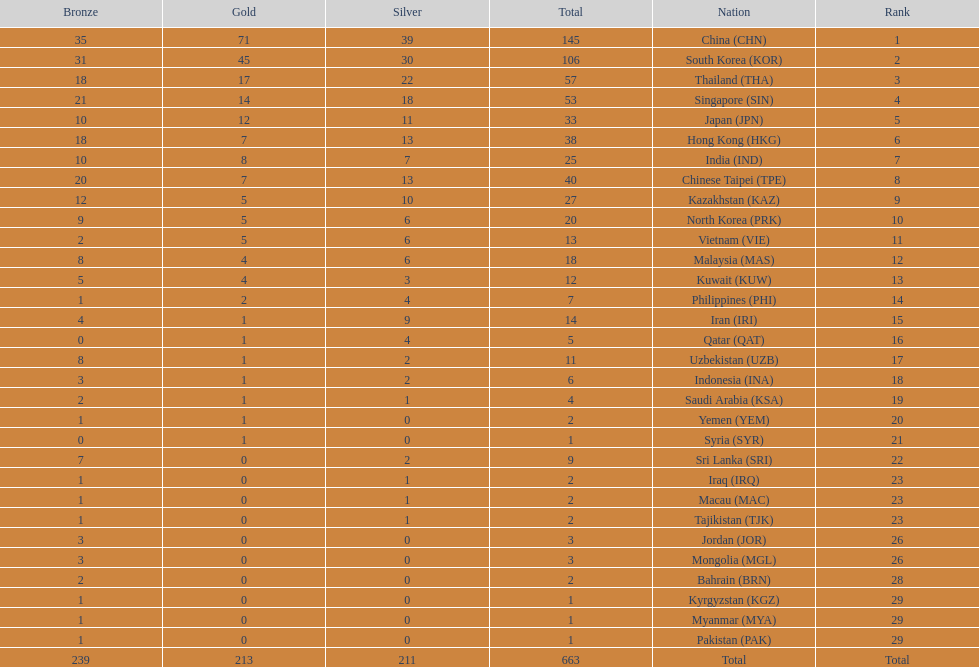Could you parse the entire table? {'header': ['Bronze', 'Gold', 'Silver', 'Total', 'Nation', 'Rank'], 'rows': [['35', '71', '39', '145', 'China\xa0(CHN)', '1'], ['31', '45', '30', '106', 'South Korea\xa0(KOR)', '2'], ['18', '17', '22', '57', 'Thailand\xa0(THA)', '3'], ['21', '14', '18', '53', 'Singapore\xa0(SIN)', '4'], ['10', '12', '11', '33', 'Japan\xa0(JPN)', '5'], ['18', '7', '13', '38', 'Hong Kong\xa0(HKG)', '6'], ['10', '8', '7', '25', 'India\xa0(IND)', '7'], ['20', '7', '13', '40', 'Chinese Taipei\xa0(TPE)', '8'], ['12', '5', '10', '27', 'Kazakhstan\xa0(KAZ)', '9'], ['9', '5', '6', '20', 'North Korea\xa0(PRK)', '10'], ['2', '5', '6', '13', 'Vietnam\xa0(VIE)', '11'], ['8', '4', '6', '18', 'Malaysia\xa0(MAS)', '12'], ['5', '4', '3', '12', 'Kuwait\xa0(KUW)', '13'], ['1', '2', '4', '7', 'Philippines\xa0(PHI)', '14'], ['4', '1', '9', '14', 'Iran\xa0(IRI)', '15'], ['0', '1', '4', '5', 'Qatar\xa0(QAT)', '16'], ['8', '1', '2', '11', 'Uzbekistan\xa0(UZB)', '17'], ['3', '1', '2', '6', 'Indonesia\xa0(INA)', '18'], ['2', '1', '1', '4', 'Saudi Arabia\xa0(KSA)', '19'], ['1', '1', '0', '2', 'Yemen\xa0(YEM)', '20'], ['0', '1', '0', '1', 'Syria\xa0(SYR)', '21'], ['7', '0', '2', '9', 'Sri Lanka\xa0(SRI)', '22'], ['1', '0', '1', '2', 'Iraq\xa0(IRQ)', '23'], ['1', '0', '1', '2', 'Macau\xa0(MAC)', '23'], ['1', '0', '1', '2', 'Tajikistan\xa0(TJK)', '23'], ['3', '0', '0', '3', 'Jordan\xa0(JOR)', '26'], ['3', '0', '0', '3', 'Mongolia\xa0(MGL)', '26'], ['2', '0', '0', '2', 'Bahrain\xa0(BRN)', '28'], ['1', '0', '0', '1', 'Kyrgyzstan\xa0(KGZ)', '29'], ['1', '0', '0', '1', 'Myanmar\xa0(MYA)', '29'], ['1', '0', '0', '1', 'Pakistan\xa0(PAK)', '29'], ['239', '213', '211', '663', 'Total', 'Total']]} Which nation has more gold medals, kuwait or india? India (IND). 